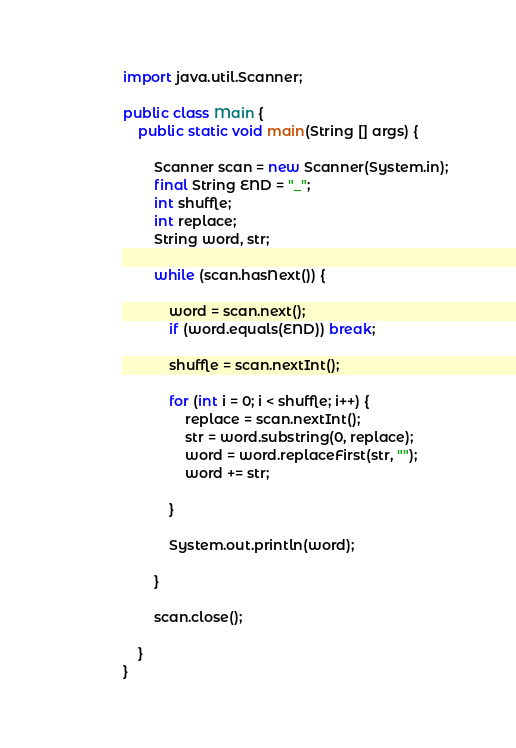Convert code to text. <code><loc_0><loc_0><loc_500><loc_500><_Java_>import java.util.Scanner;

public class Main {
	public static void main(String [] args) {
		
		Scanner scan = new Scanner(System.in);
		final String END = "_";
		int shuffle;
		int replace;
		String word, str;
		
		while (scan.hasNext()) {
			
			word = scan.next();
			if (word.equals(END)) break;
			
			shuffle = scan.nextInt();
			
			for (int i = 0; i < shuffle; i++) {
				replace = scan.nextInt();
				str = word.substring(0, replace);
				word = word.replaceFirst(str, "");
				word += str;
				
			}
			
			System.out.println(word);
			
		} 
		
		scan.close();
		
	}
}

</code> 